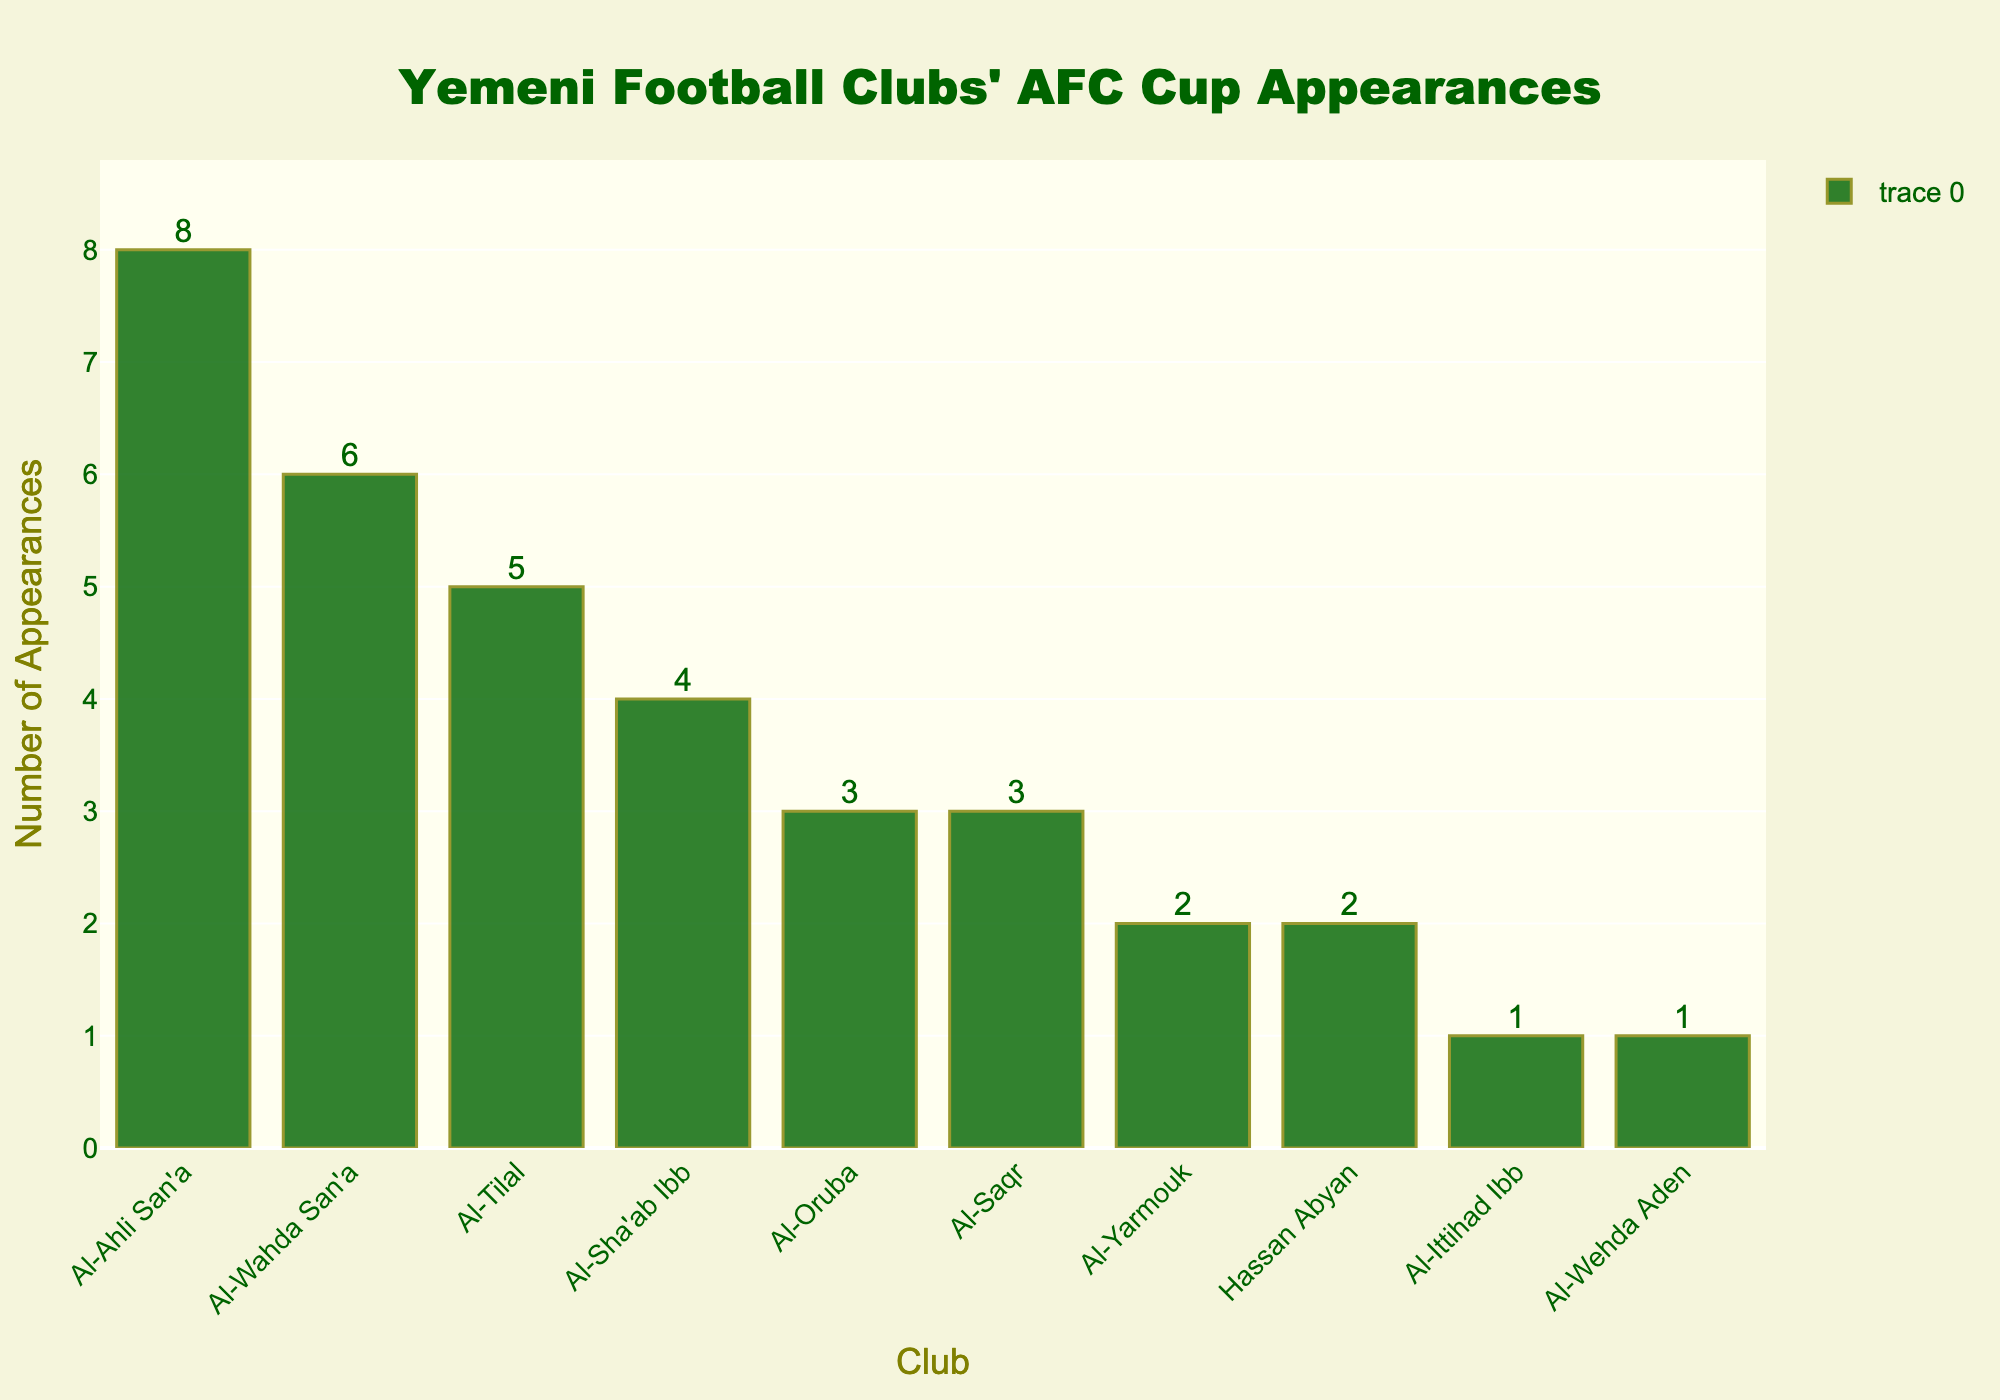What's the name of the Yemeni football club with the highest number of AFC Cup appearances? The bar with the highest height represents Al-Ahli San'a with 8 AFC Cup appearances.
Answer: Al-Ahli San'a How many more appearances does Al-Ahli San'a have compared to Al-Yarmouk? Al-Ahli San'a has 8 appearances, while Al-Yarmouk has 2. The difference is 8 - 2.
Answer: 6 What is the total number of AFC Cup appearances made by Al-Wahda San'a and Al-Tilal combined? Al-Wahda San'a has 6 appearances, and Al-Tilal has 5 appearances. The total is 6 + 5.
Answer: 11 Which club has the lowest number of AFC Cup appearances, and how many appearances is that? Both Al-Ittihad Ibb and Al-Wehda Aden have the lowest number of appearances, each with 1.
Answer: Al-Ittihad Ibb and Al-Wehda Aden - 1 How many clubs have made at least 3 AFC Cup appearances? Count the clubs with appearances of 3 or more: Al-Ahli San'a (8), Al-Wahda San'a (6), Al-Tilal (5), Al-Sha'ab Ibb (4), Al-Oruba (3), Al-Saqr (3). There are 6 clubs.
Answer: 6 What is the average number of AFC Cup appearances for all listed clubs? Sum all appearances (8 + 6 + 5 + 4 + 3 + 3 + 2 + 2 + 1 + 1) = 35. There are 10 clubs, so the average is 35 / 10.
Answer: 3.5 Which clubs have the same number of AFC Cup appearances, and how many appearances do they have? Both Al-Oruba and Al-Saqr have 3 appearances each; both Al-Yarmouk and Hassan Abyan have 2 appearances each.
Answer: Al-Oruba and Al-Saqr - 3, Al-Yarmouk and Hassan Abyan - 2 